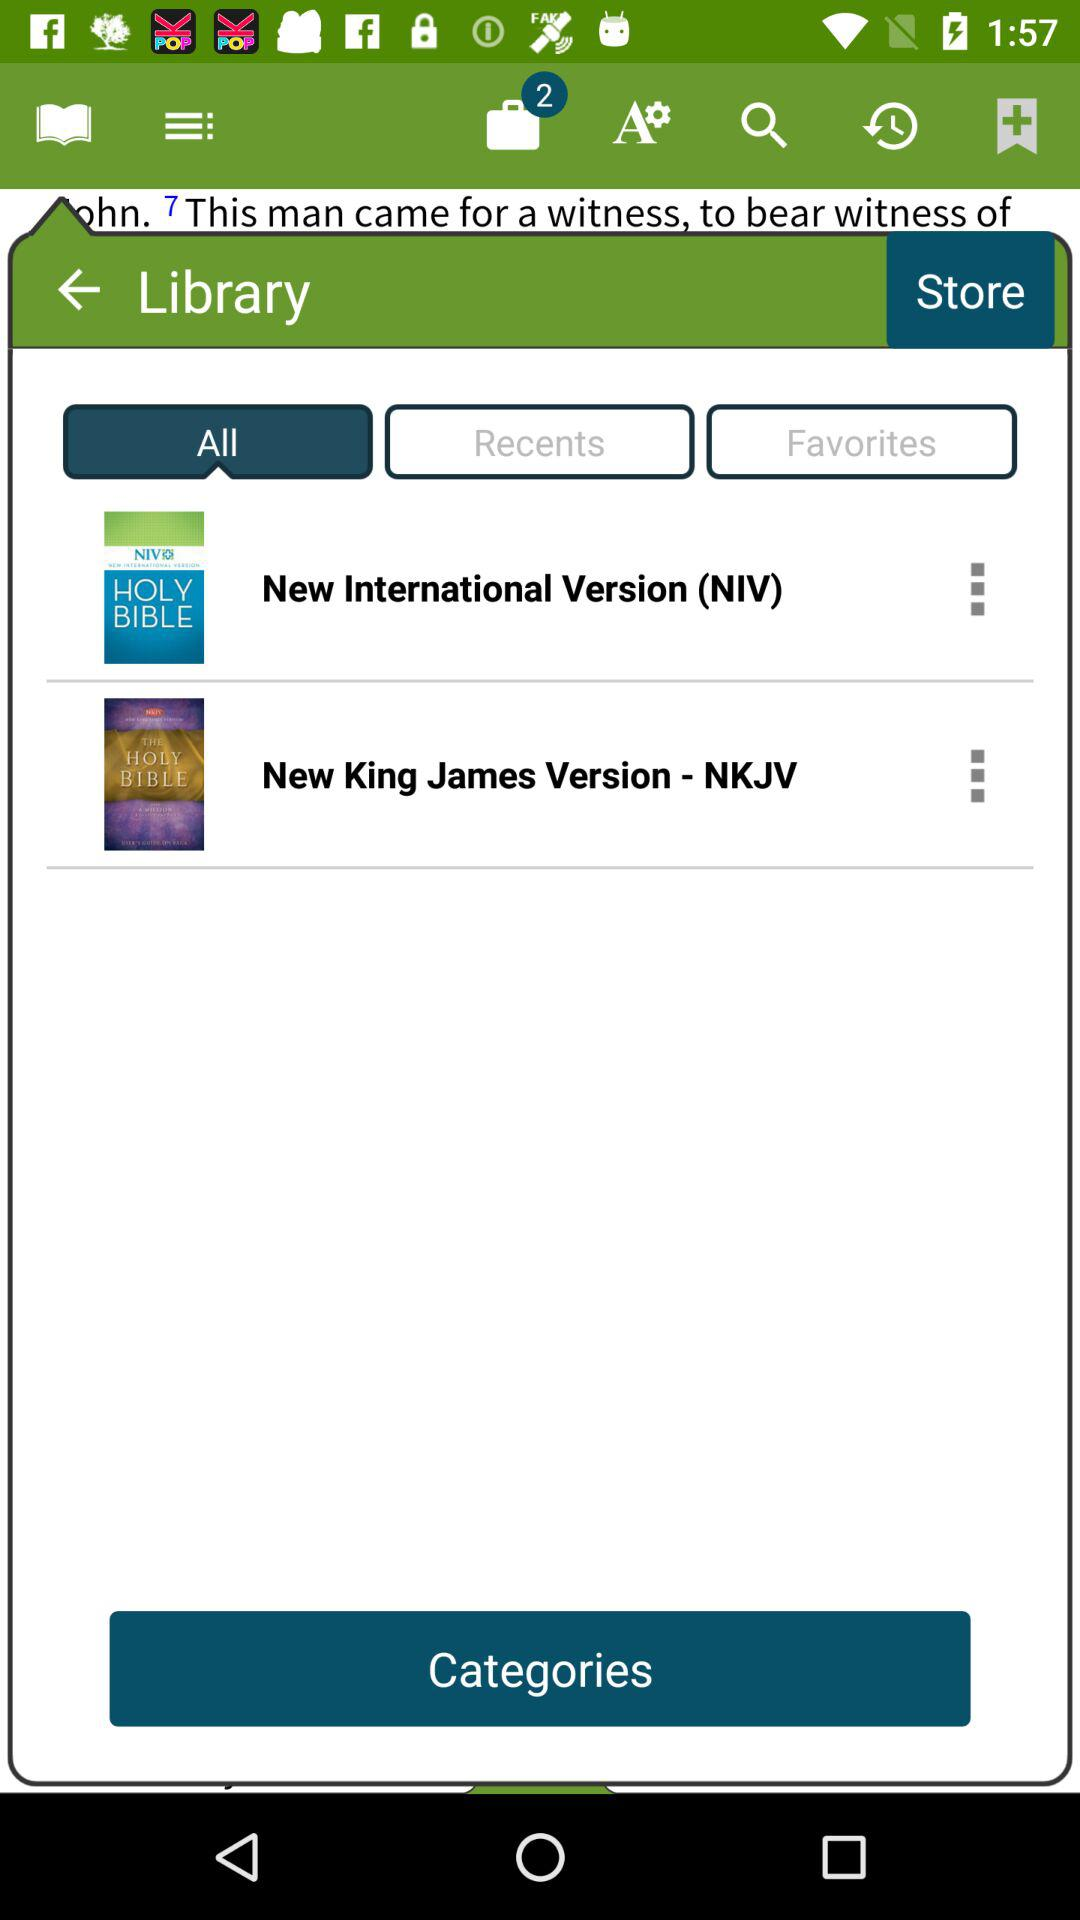How many items are in the bag? There are 2 items in the bag. 